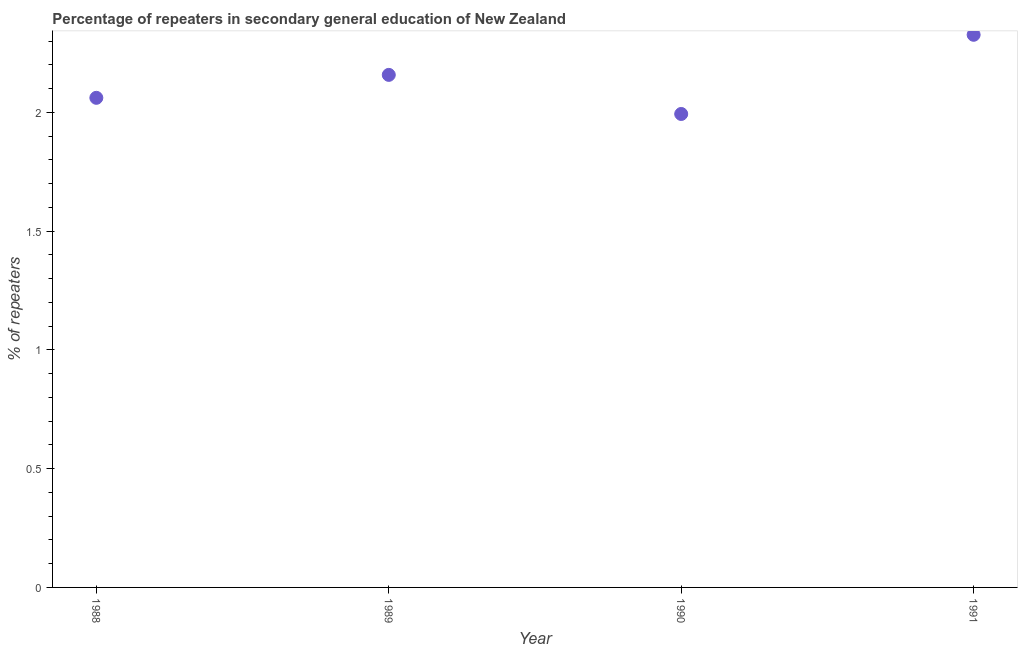What is the percentage of repeaters in 1990?
Offer a very short reply. 1.99. Across all years, what is the maximum percentage of repeaters?
Your answer should be very brief. 2.33. Across all years, what is the minimum percentage of repeaters?
Provide a short and direct response. 1.99. In which year was the percentage of repeaters minimum?
Give a very brief answer. 1990. What is the sum of the percentage of repeaters?
Offer a terse response. 8.54. What is the difference between the percentage of repeaters in 1989 and 1990?
Keep it short and to the point. 0.16. What is the average percentage of repeaters per year?
Provide a succinct answer. 2.13. What is the median percentage of repeaters?
Ensure brevity in your answer.  2.11. Do a majority of the years between 1991 and 1988 (inclusive) have percentage of repeaters greater than 0.8 %?
Offer a very short reply. Yes. What is the ratio of the percentage of repeaters in 1988 to that in 1989?
Make the answer very short. 0.96. What is the difference between the highest and the second highest percentage of repeaters?
Give a very brief answer. 0.17. What is the difference between the highest and the lowest percentage of repeaters?
Make the answer very short. 0.33. In how many years, is the percentage of repeaters greater than the average percentage of repeaters taken over all years?
Provide a short and direct response. 2. Does the percentage of repeaters monotonically increase over the years?
Provide a succinct answer. No. How many dotlines are there?
Offer a terse response. 1. How many years are there in the graph?
Give a very brief answer. 4. Are the values on the major ticks of Y-axis written in scientific E-notation?
Your response must be concise. No. What is the title of the graph?
Provide a succinct answer. Percentage of repeaters in secondary general education of New Zealand. What is the label or title of the Y-axis?
Give a very brief answer. % of repeaters. What is the % of repeaters in 1988?
Your response must be concise. 2.06. What is the % of repeaters in 1989?
Your answer should be compact. 2.16. What is the % of repeaters in 1990?
Your answer should be compact. 1.99. What is the % of repeaters in 1991?
Provide a short and direct response. 2.33. What is the difference between the % of repeaters in 1988 and 1989?
Your response must be concise. -0.1. What is the difference between the % of repeaters in 1988 and 1990?
Offer a very short reply. 0.07. What is the difference between the % of repeaters in 1988 and 1991?
Your response must be concise. -0.27. What is the difference between the % of repeaters in 1989 and 1990?
Provide a succinct answer. 0.16. What is the difference between the % of repeaters in 1989 and 1991?
Your answer should be compact. -0.17. What is the difference between the % of repeaters in 1990 and 1991?
Your response must be concise. -0.33. What is the ratio of the % of repeaters in 1988 to that in 1989?
Provide a succinct answer. 0.95. What is the ratio of the % of repeaters in 1988 to that in 1990?
Give a very brief answer. 1.03. What is the ratio of the % of repeaters in 1988 to that in 1991?
Offer a terse response. 0.89. What is the ratio of the % of repeaters in 1989 to that in 1990?
Provide a short and direct response. 1.08. What is the ratio of the % of repeaters in 1989 to that in 1991?
Ensure brevity in your answer.  0.93. What is the ratio of the % of repeaters in 1990 to that in 1991?
Ensure brevity in your answer.  0.86. 